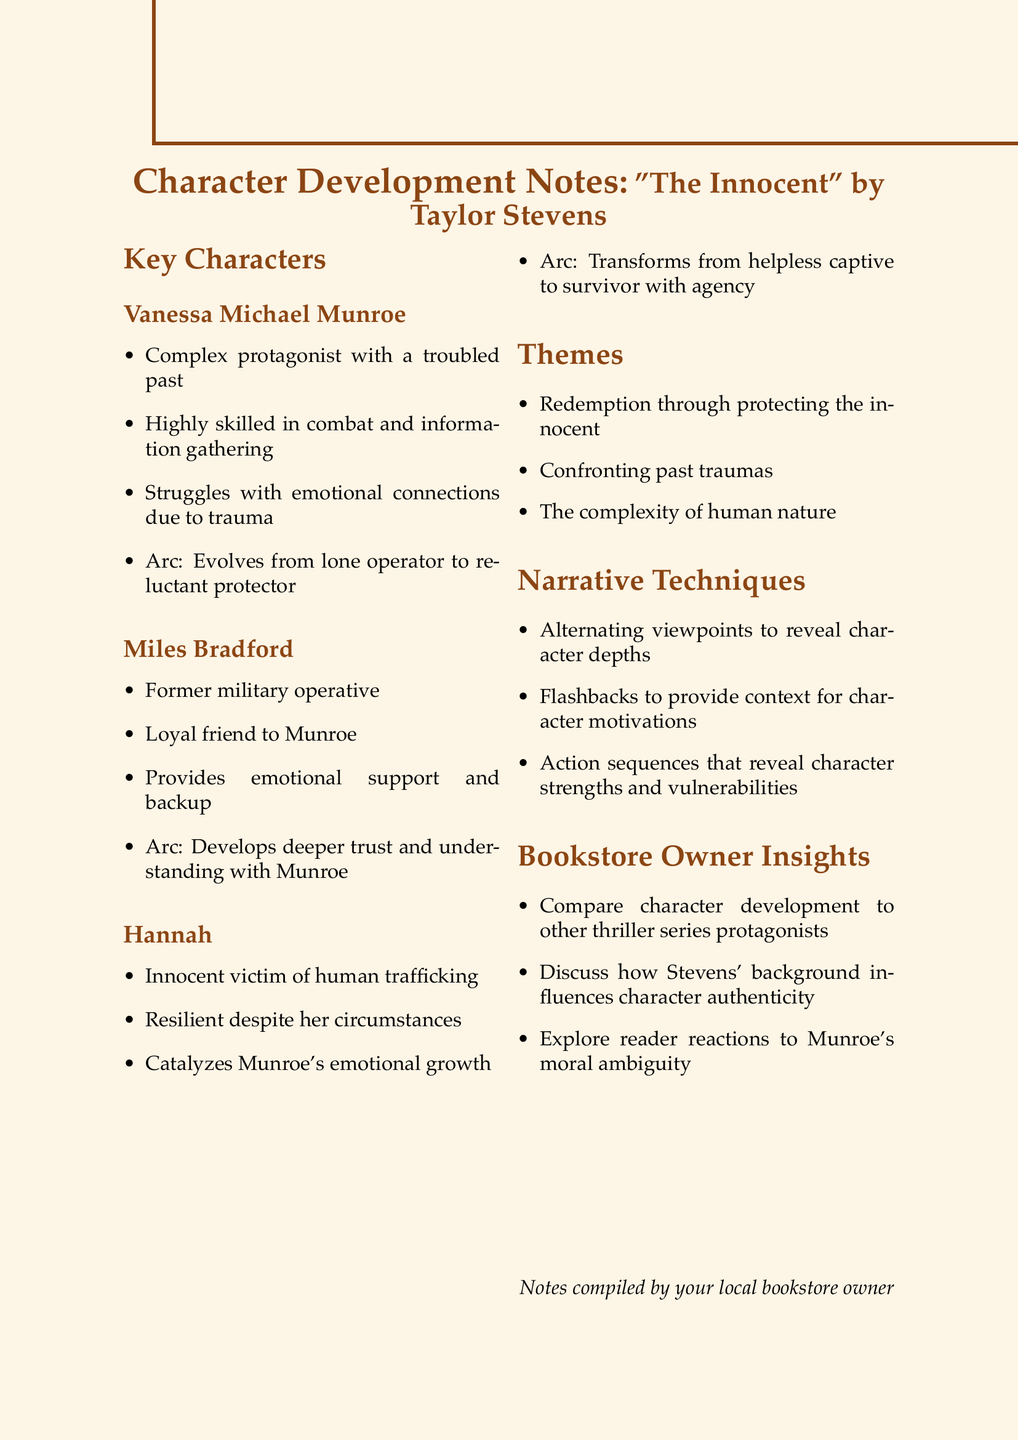What is the protagonist's name? The document states that the complex protagonist is named Vanessa Michael Munroe.
Answer: Vanessa Michael Munroe What arc does Vanessa Michael Munroe experience? The document reveals that her arc evolves from a lone operator to a reluctant protector.
Answer: Evolves from lone operator to reluctant protector Who provides emotional support to Munroe? The document mentions Miles Bradford as a loyal friend providing emotional support and backup.
Answer: Miles Bradford What is Hannah's role in the story? The notes describe Hannah as an innocent victim of human trafficking who catalyzes Munroe's emotional growth.
Answer: Catalyzes Munroe's emotional growth What theme relates to confronting personal history? The document lists "Confronting past traumas" as a key theme.
Answer: Confronting past traumas What narrative technique reveals character strengths? The document indicates that action sequences reveal character strengths and vulnerabilities.
Answer: Action sequences How does the character Hannah transform? The document states that she transforms from a helpless captive to a survivor with agency.
Answer: From helpless captive to survivor with agency What is one insight for bookstore owners? The notes suggest discussing how Stevens' background influences character authenticity as an insight.
Answer: Stevens' background influences character authenticity What skill is Vanessa Michael Munroe highly skilled in? The document states that she is highly skilled in combat and information gathering.
Answer: Combat and information gathering How does Miles Bradford's relationship with Munroe develop? The notes explain that he develops deeper trust and understanding with Munroe.
Answer: Deeper trust and understanding with Munroe 